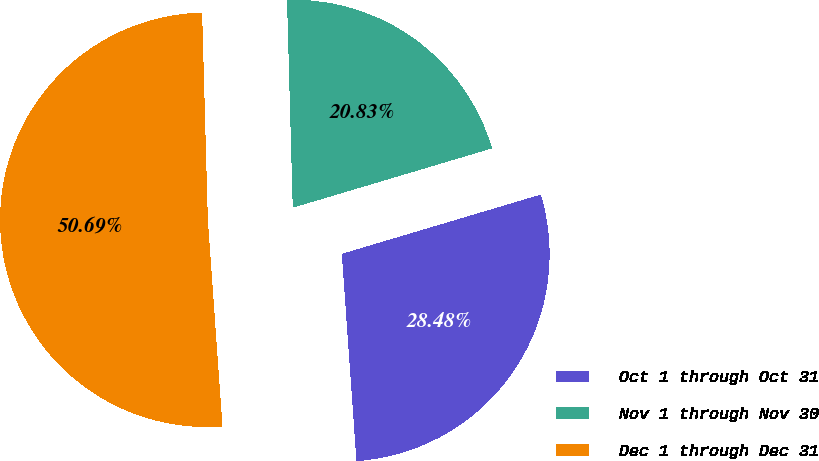<chart> <loc_0><loc_0><loc_500><loc_500><pie_chart><fcel>Oct 1 through Oct 31<fcel>Nov 1 through Nov 30<fcel>Dec 1 through Dec 31<nl><fcel>28.48%<fcel>20.83%<fcel>50.68%<nl></chart> 